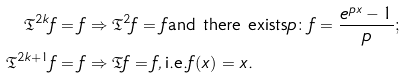<formula> <loc_0><loc_0><loc_500><loc_500>\mathfrak { T } ^ { 2 k } f & = f \Rightarrow \mathfrak { T } ^ { 2 } f = f \text {and there exists} p \colon f = \frac { e ^ { p x } - 1 } { p } ; \\ \mathfrak { T } ^ { 2 k + 1 } f & = f \Rightarrow \mathfrak { T } f = f , \text {i.e.} f ( x ) = x .</formula> 